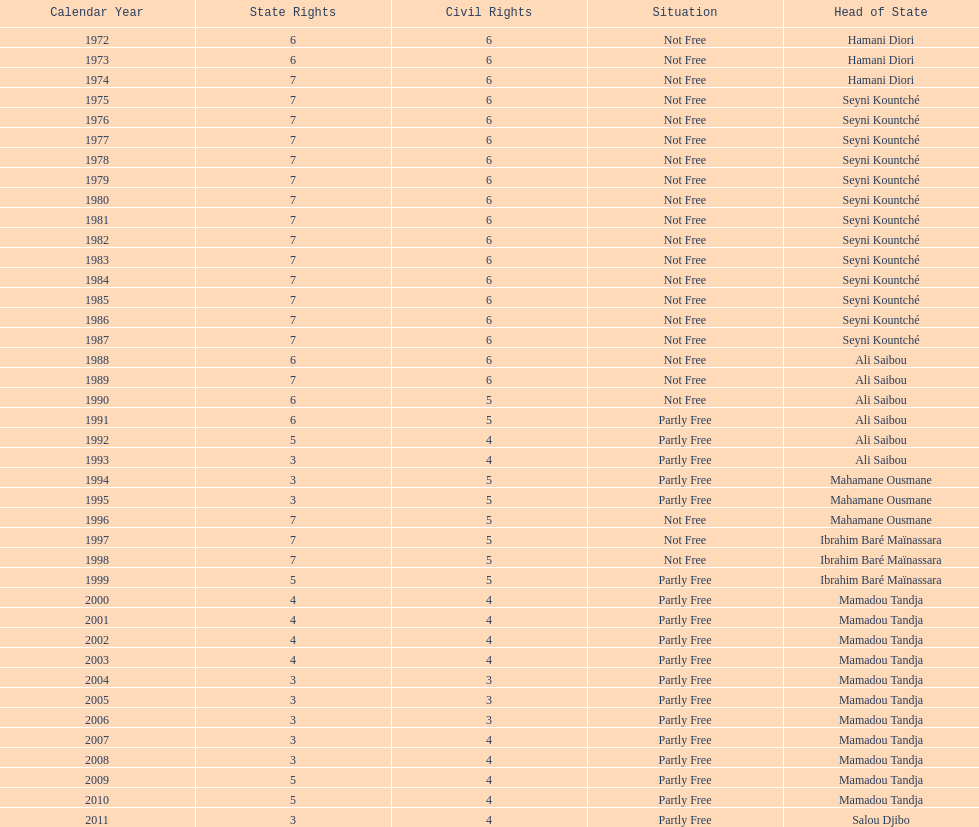How long did it take for civil liberties to decrease below 6? 18 years. 